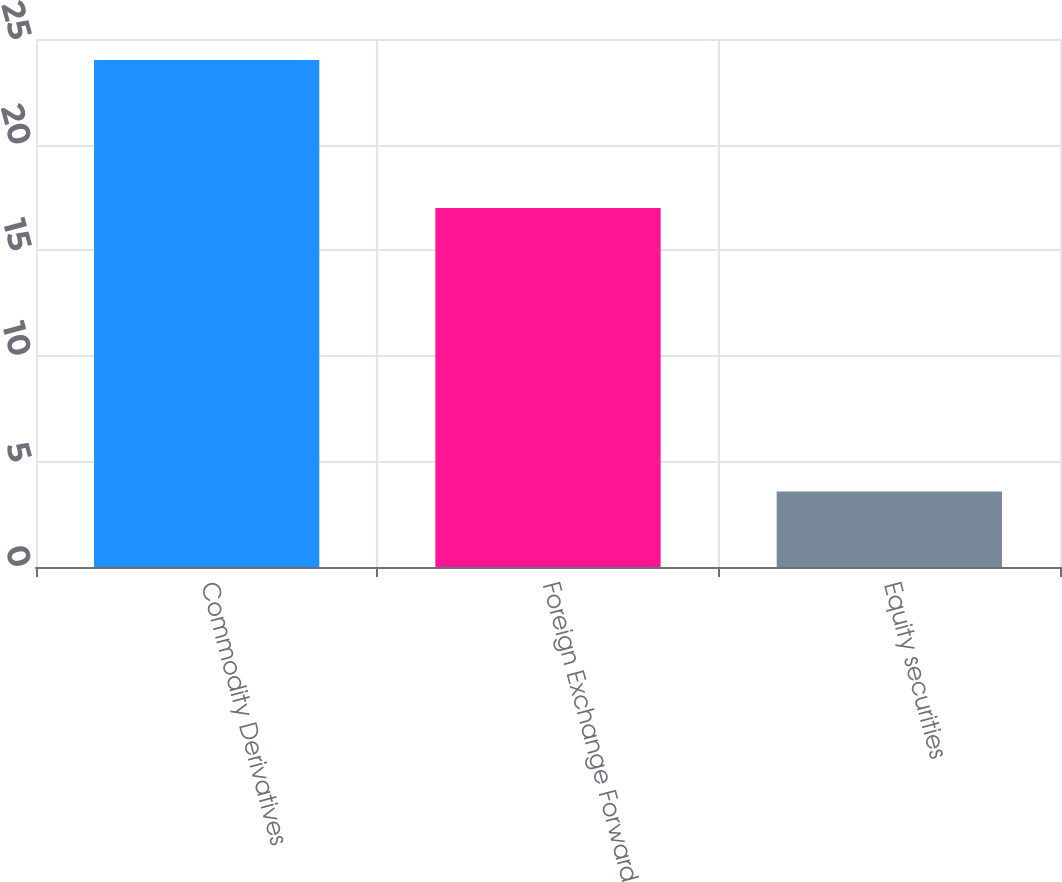Convert chart to OTSL. <chart><loc_0><loc_0><loc_500><loc_500><bar_chart><fcel>Commodity Derivatives<fcel>Foreign Exchange Forward<fcel>Equity securities<nl><fcel>24<fcel>17<fcel>3.57<nl></chart> 